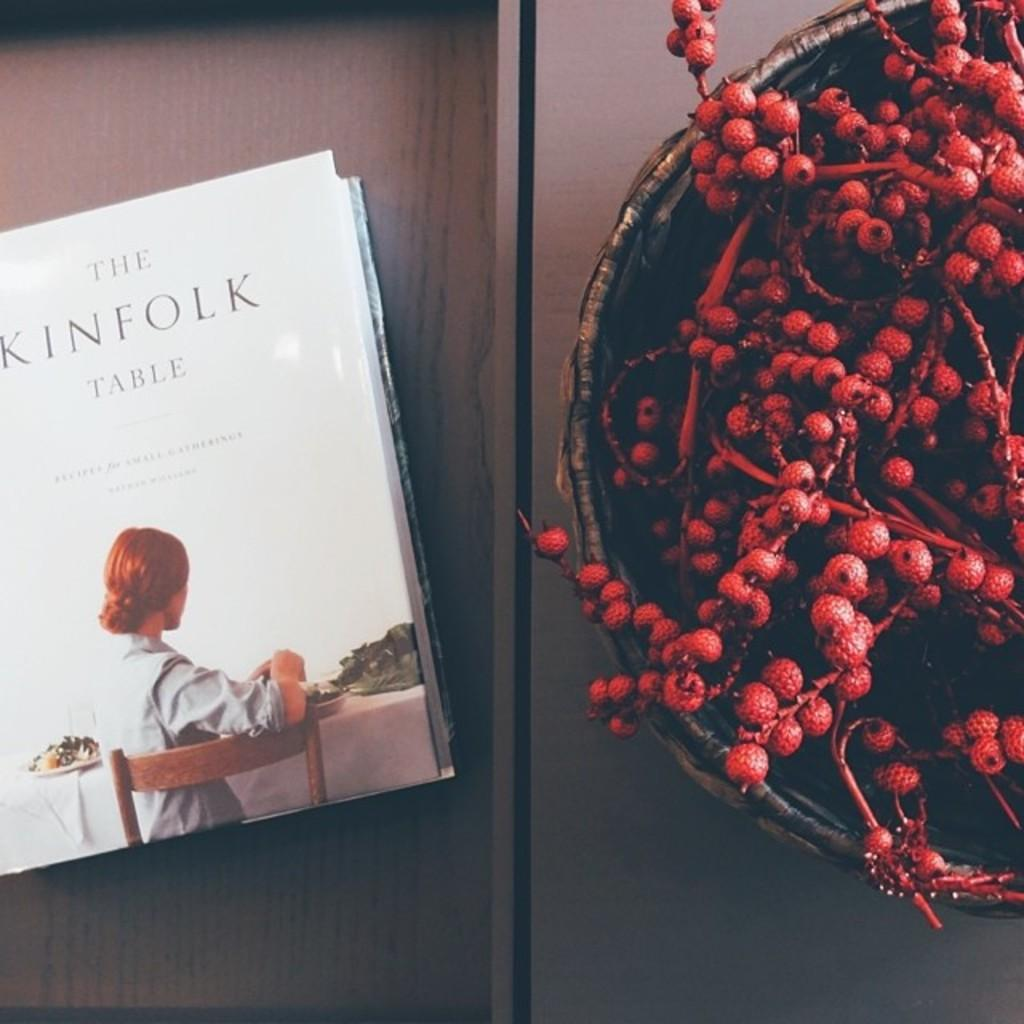<image>
Create a compact narrative representing the image presented. A cooking book has a title of The Kinfolk Table. 